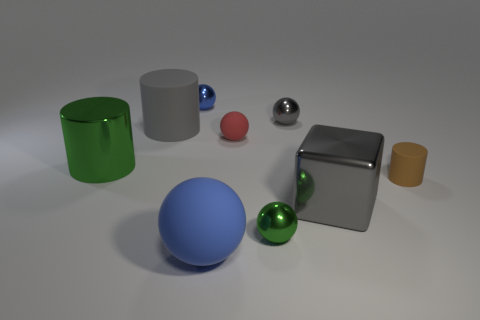Are there any other things that are the same color as the tiny rubber sphere?
Keep it short and to the point. No. There is a small object that is in front of the small red thing and on the right side of the green ball; what is its material?
Your answer should be very brief. Rubber. How many other things are there of the same size as the blue matte object?
Keep it short and to the point. 3. The small cylinder is what color?
Ensure brevity in your answer.  Brown. Does the tiny metal object in front of the red object have the same color as the shiny thing on the left side of the small blue thing?
Provide a short and direct response. Yes. The brown matte object has what size?
Provide a short and direct response. Small. There is a green metallic thing that is to the right of the large gray rubber thing; what is its size?
Give a very brief answer. Small. What is the shape of the tiny object that is both on the right side of the tiny green object and in front of the big shiny cylinder?
Provide a succinct answer. Cylinder. How many other objects are there of the same shape as the brown rubber object?
Give a very brief answer. 2. What color is the cylinder that is the same size as the gray sphere?
Your response must be concise. Brown. 